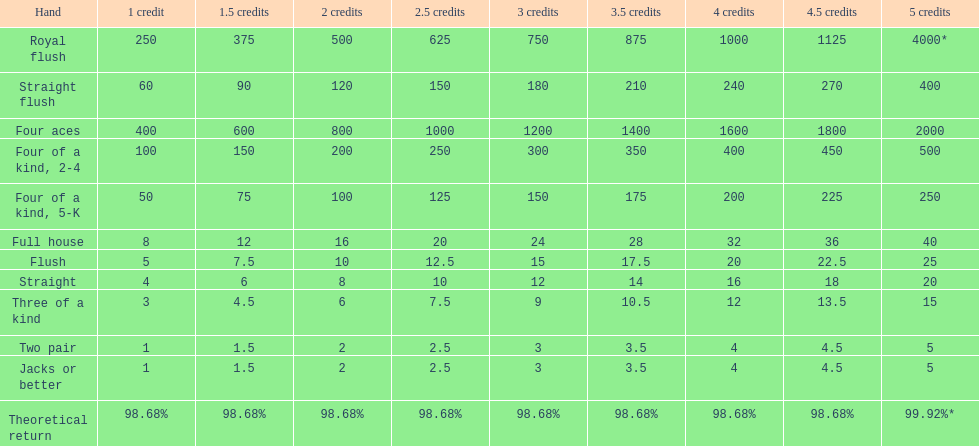How many straight wins at 3 credits equals one straight flush win at two credits? 10. 